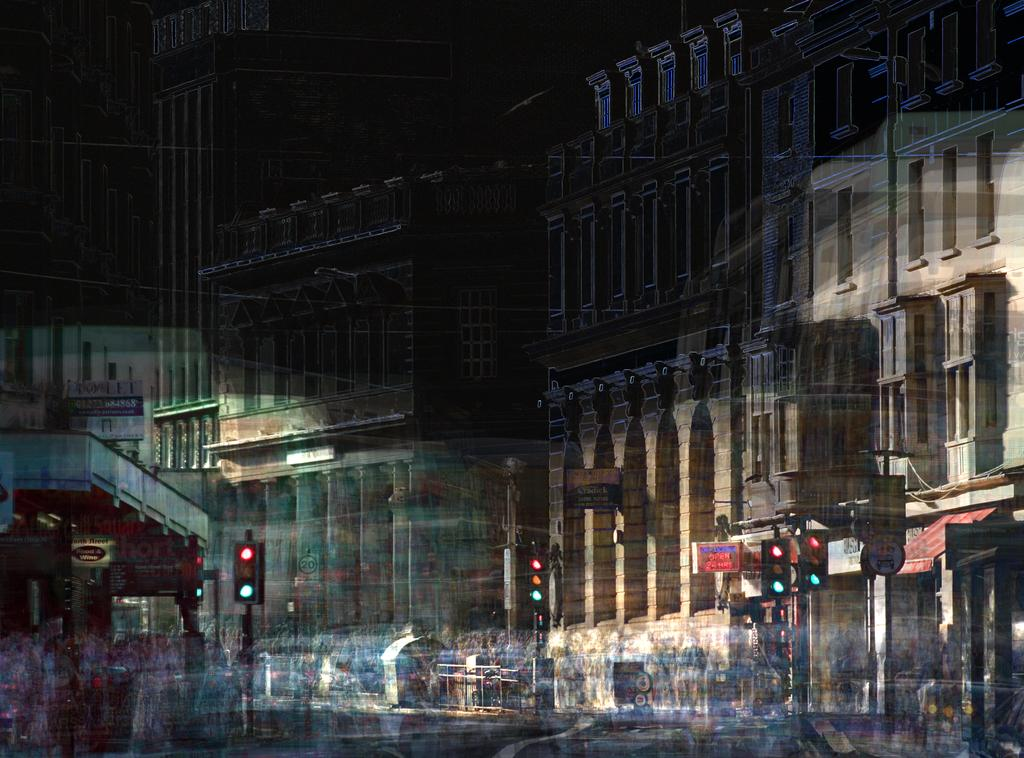What type of structures can be seen in the image? There are buildings in the image. What else can be seen in the image besides the buildings? There are signal poles in the image. What type of berry can be seen growing on the signal poles in the image? There are no berries present on the signal poles in the image. What color is the banana that is being used as a decoration on the buildings in the image? There are no bananas present as decorations on the buildings in the image. 